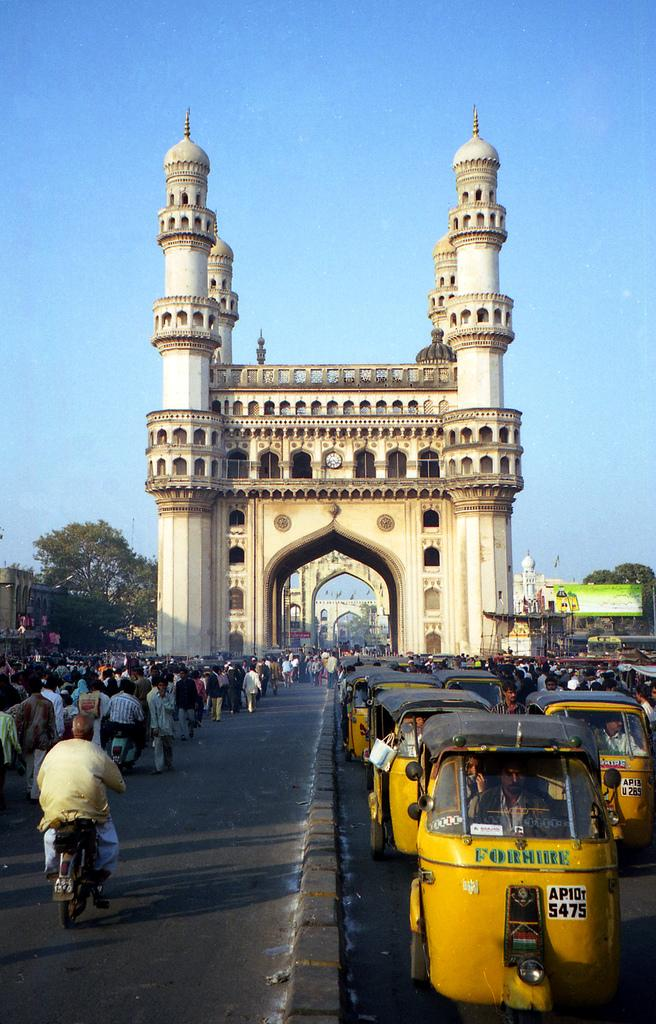<image>
Relay a brief, clear account of the picture shown. The sign on the yellow vehicles lets others know they are for hire. 